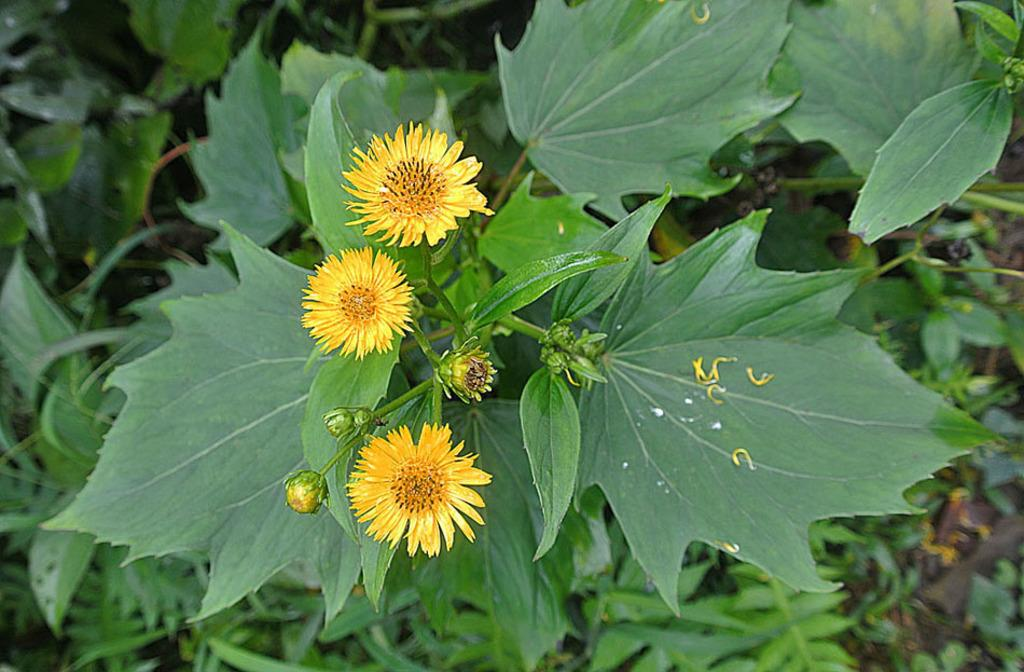What type of plants can be seen in the image? There are flowering plants in the image. What other type of vegetation is present in the image? There is grass in the image. Where might this image have been taken? The image may have been taken in a garden, given the presence of flowering plants and grass. What type of pen is visible in the image? There is no pen present in the image. Is there any sand visible in the image? There is no sand visible in the image. 